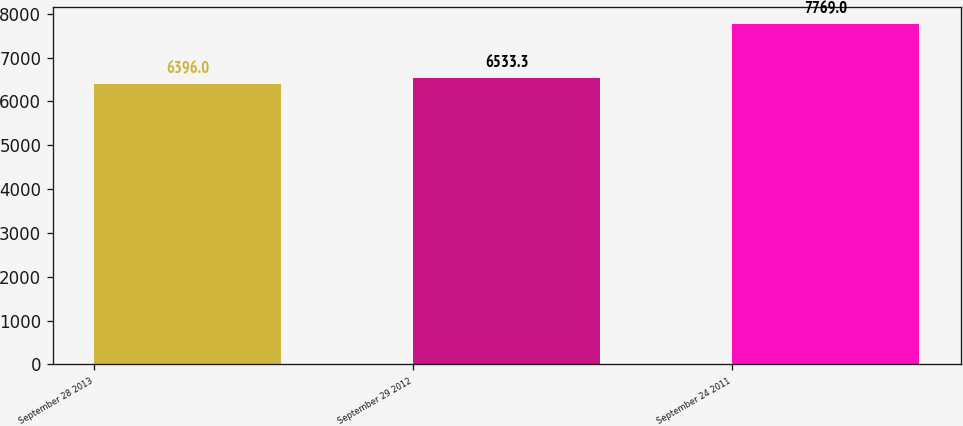<chart> <loc_0><loc_0><loc_500><loc_500><bar_chart><fcel>September 28 2013<fcel>September 29 2012<fcel>September 24 2011<nl><fcel>6396<fcel>6533.3<fcel>7769<nl></chart> 